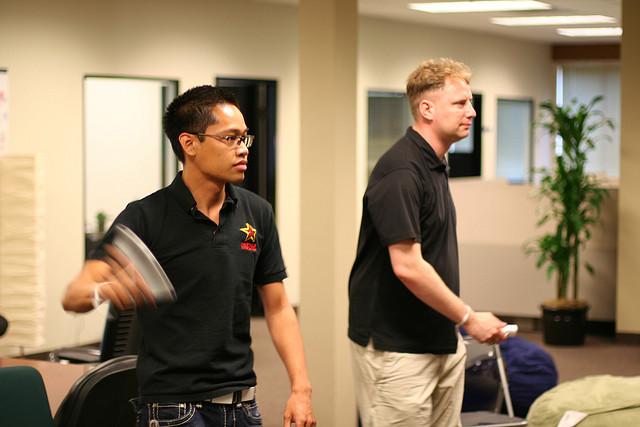What kind of remote is in their hands?
Answer briefly. Wii. Are there plants in the room?
Quick response, please. Yes. What color is the shorter man's belt?
Give a very brief answer. White. 